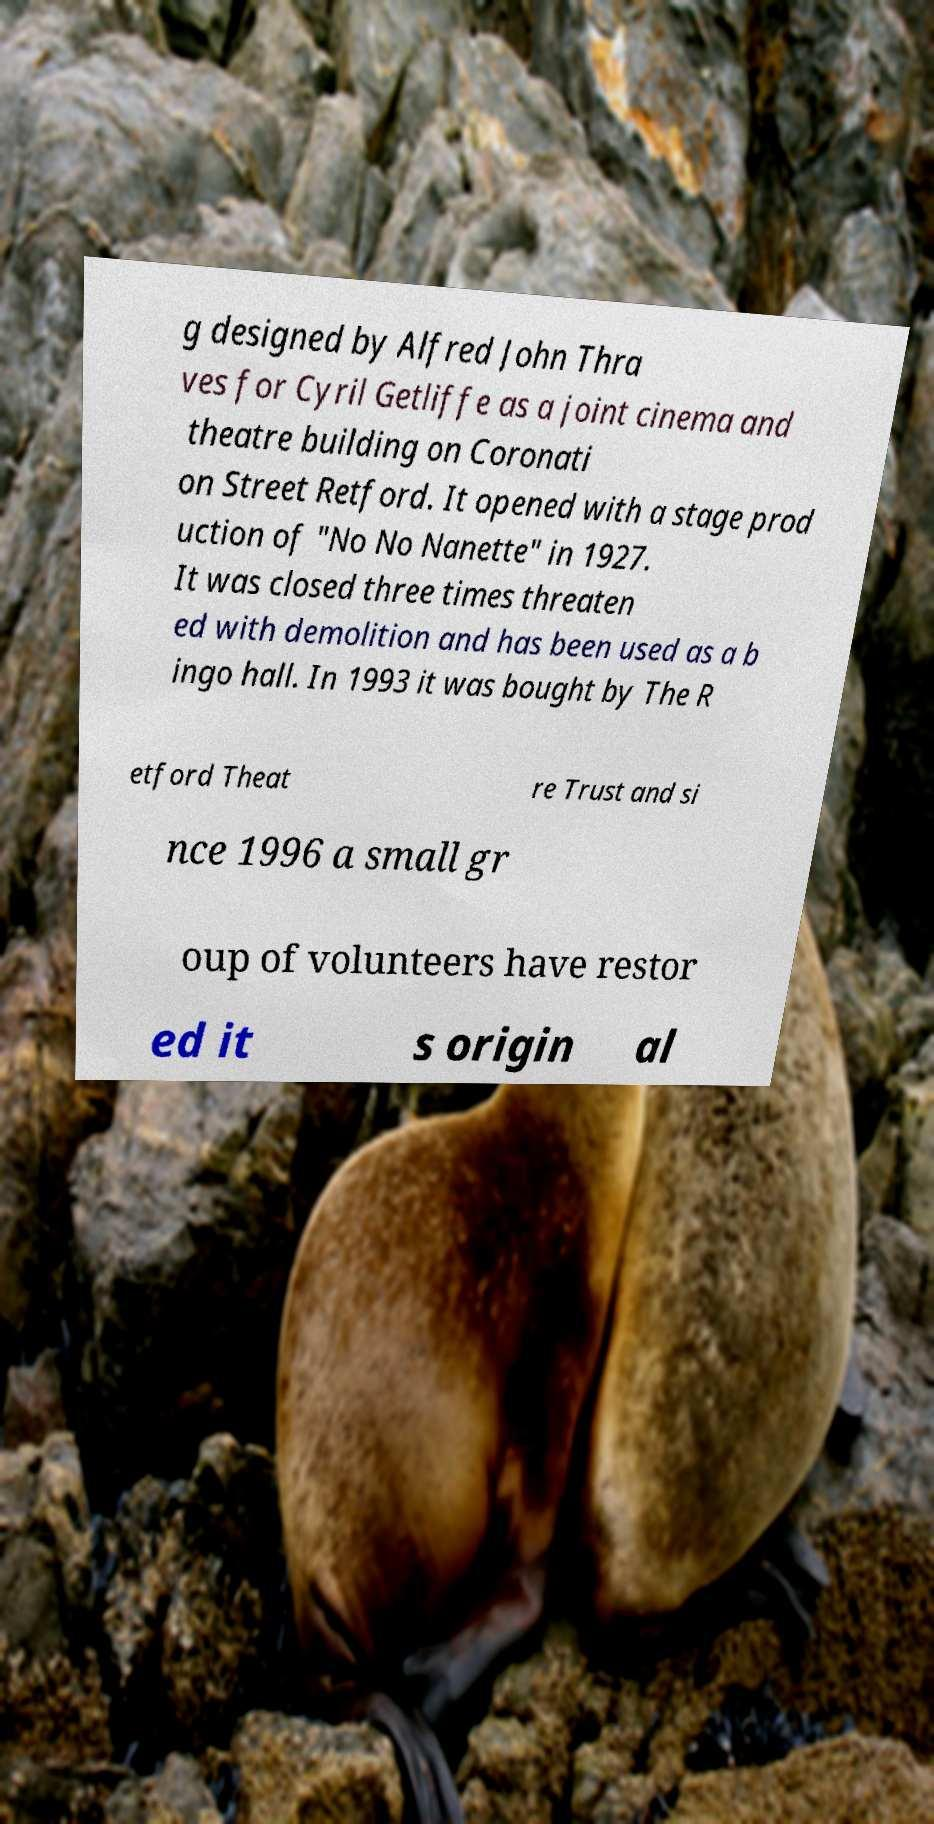Could you extract and type out the text from this image? g designed by Alfred John Thra ves for Cyril Getliffe as a joint cinema and theatre building on Coronati on Street Retford. It opened with a stage prod uction of "No No Nanette" in 1927. It was closed three times threaten ed with demolition and has been used as a b ingo hall. In 1993 it was bought by The R etford Theat re Trust and si nce 1996 a small gr oup of volunteers have restor ed it s origin al 